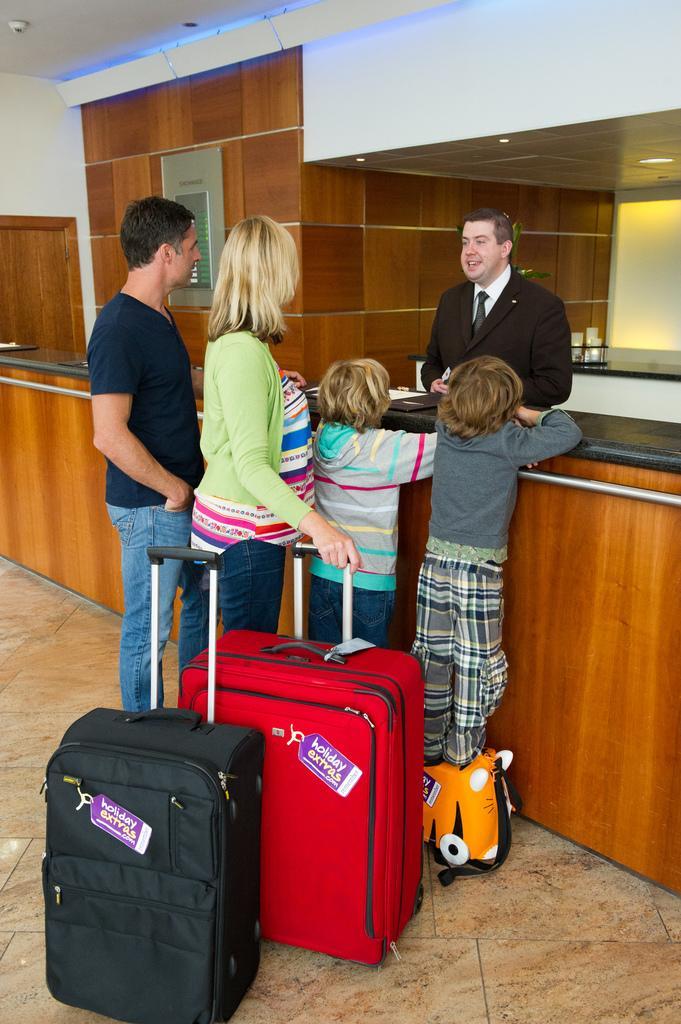How would you summarize this image in a sentence or two? In this picture we can see a family with man and woman standing here the children are trying to climb on the table and on other side person wore blazer, tie talking to them and here beside to them we can see bag, suitcase with tags and in background we can see wall, wooden door, light. 